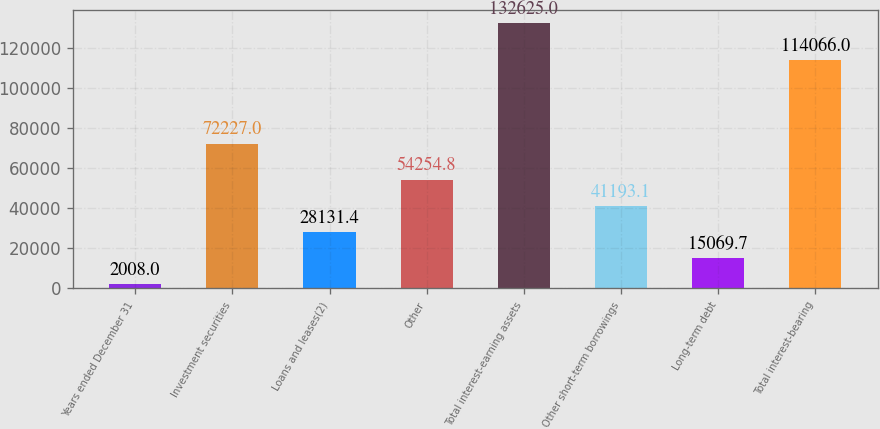<chart> <loc_0><loc_0><loc_500><loc_500><bar_chart><fcel>Years ended December 31<fcel>Investment securities<fcel>Loans and leases(2)<fcel>Other<fcel>Total interest-earning assets<fcel>Other short-term borrowings<fcel>Long-term debt<fcel>Total interest-bearing<nl><fcel>2008<fcel>72227<fcel>28131.4<fcel>54254.8<fcel>132625<fcel>41193.1<fcel>15069.7<fcel>114066<nl></chart> 